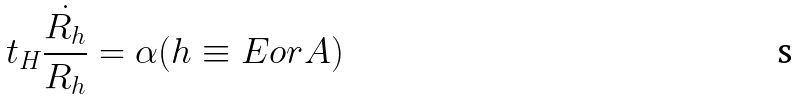Convert formula to latex. <formula><loc_0><loc_0><loc_500><loc_500>t _ { H } \frac { \dot { R _ { h } } } { R _ { h } } = \alpha ( h \equiv E o r A )</formula> 